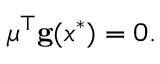Convert formula to latex. <formula><loc_0><loc_0><loc_500><loc_500>{ \mu } ^ { \top } g ( x ^ { * } ) = 0 .</formula> 